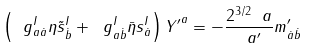Convert formula to latex. <formula><loc_0><loc_0><loc_500><loc_500>\left ( \ g ^ { I } _ { a \dot { a } } \eta \tilde { s } ^ { I } _ { \dot { b } } + \ g ^ { I } _ { a \dot { b } } \bar { \eta } s ^ { I } _ { \dot { a } } \right ) { Y ^ { \prime } } ^ { a } = - \frac { 2 ^ { 3 / 2 } \ a } { \ a ^ { \prime } } m ^ { \prime } _ { \dot { a } \dot { b } }</formula> 